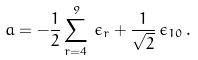Convert formula to latex. <formula><loc_0><loc_0><loc_500><loc_500>a = - { \frac { 1 } { 2 } } \sum _ { r = 4 } ^ { 9 } \, \epsilon _ { r } + { \frac { 1 } { \sqrt { 2 } } } \, \epsilon _ { 1 0 } \, .</formula> 